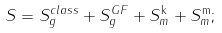Convert formula to latex. <formula><loc_0><loc_0><loc_500><loc_500>S = S _ { g } ^ { c l a s s } + S _ { g } ^ { G F } + S _ { m } ^ { \mathrm k } + S _ { m } ^ { \mathrm m } ;</formula> 